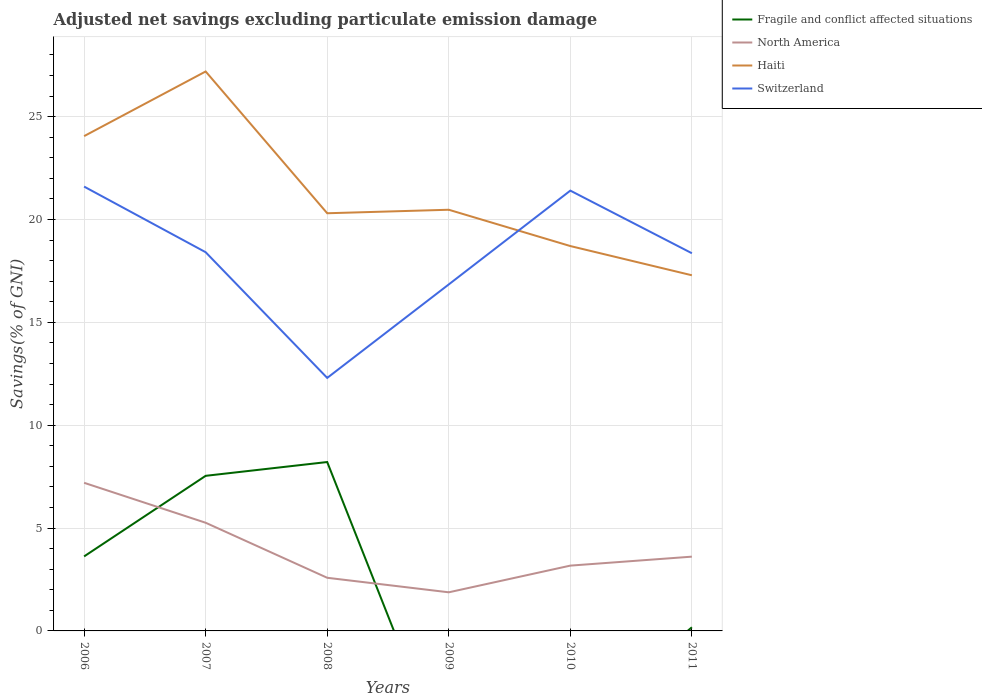How many different coloured lines are there?
Provide a succinct answer. 4. Is the number of lines equal to the number of legend labels?
Keep it short and to the point. No. Across all years, what is the maximum adjusted net savings in North America?
Offer a terse response. 1.88. What is the total adjusted net savings in Haiti in the graph?
Your response must be concise. 1.42. What is the difference between the highest and the second highest adjusted net savings in Haiti?
Provide a short and direct response. 9.91. How many years are there in the graph?
Give a very brief answer. 6. Does the graph contain any zero values?
Your answer should be compact. Yes. Does the graph contain grids?
Provide a succinct answer. Yes. Where does the legend appear in the graph?
Your answer should be compact. Top right. How many legend labels are there?
Ensure brevity in your answer.  4. What is the title of the graph?
Make the answer very short. Adjusted net savings excluding particulate emission damage. What is the label or title of the X-axis?
Provide a short and direct response. Years. What is the label or title of the Y-axis?
Offer a very short reply. Savings(% of GNI). What is the Savings(% of GNI) in Fragile and conflict affected situations in 2006?
Provide a succinct answer. 3.62. What is the Savings(% of GNI) of North America in 2006?
Make the answer very short. 7.2. What is the Savings(% of GNI) of Haiti in 2006?
Provide a short and direct response. 24.05. What is the Savings(% of GNI) in Switzerland in 2006?
Your response must be concise. 21.6. What is the Savings(% of GNI) in Fragile and conflict affected situations in 2007?
Keep it short and to the point. 7.54. What is the Savings(% of GNI) of North America in 2007?
Your answer should be very brief. 5.26. What is the Savings(% of GNI) in Haiti in 2007?
Offer a terse response. 27.19. What is the Savings(% of GNI) in Switzerland in 2007?
Your answer should be compact. 18.41. What is the Savings(% of GNI) of Fragile and conflict affected situations in 2008?
Offer a very short reply. 8.21. What is the Savings(% of GNI) in North America in 2008?
Keep it short and to the point. 2.58. What is the Savings(% of GNI) in Haiti in 2008?
Give a very brief answer. 20.3. What is the Savings(% of GNI) in Switzerland in 2008?
Provide a succinct answer. 12.3. What is the Savings(% of GNI) of Fragile and conflict affected situations in 2009?
Your response must be concise. 0. What is the Savings(% of GNI) in North America in 2009?
Provide a short and direct response. 1.88. What is the Savings(% of GNI) of Haiti in 2009?
Offer a terse response. 20.47. What is the Savings(% of GNI) in Switzerland in 2009?
Ensure brevity in your answer.  16.84. What is the Savings(% of GNI) of North America in 2010?
Your answer should be compact. 3.17. What is the Savings(% of GNI) in Haiti in 2010?
Your answer should be compact. 18.71. What is the Savings(% of GNI) of Switzerland in 2010?
Ensure brevity in your answer.  21.4. What is the Savings(% of GNI) in Fragile and conflict affected situations in 2011?
Offer a very short reply. 0.18. What is the Savings(% of GNI) of North America in 2011?
Provide a short and direct response. 3.61. What is the Savings(% of GNI) in Haiti in 2011?
Offer a very short reply. 17.29. What is the Savings(% of GNI) of Switzerland in 2011?
Your response must be concise. 18.36. Across all years, what is the maximum Savings(% of GNI) in Fragile and conflict affected situations?
Give a very brief answer. 8.21. Across all years, what is the maximum Savings(% of GNI) of North America?
Your answer should be compact. 7.2. Across all years, what is the maximum Savings(% of GNI) in Haiti?
Provide a short and direct response. 27.19. Across all years, what is the maximum Savings(% of GNI) of Switzerland?
Provide a succinct answer. 21.6. Across all years, what is the minimum Savings(% of GNI) of North America?
Your response must be concise. 1.88. Across all years, what is the minimum Savings(% of GNI) in Haiti?
Provide a succinct answer. 17.29. Across all years, what is the minimum Savings(% of GNI) in Switzerland?
Provide a succinct answer. 12.3. What is the total Savings(% of GNI) of Fragile and conflict affected situations in the graph?
Give a very brief answer. 19.55. What is the total Savings(% of GNI) in North America in the graph?
Your response must be concise. 23.7. What is the total Savings(% of GNI) in Haiti in the graph?
Provide a short and direct response. 128.02. What is the total Savings(% of GNI) of Switzerland in the graph?
Your response must be concise. 108.91. What is the difference between the Savings(% of GNI) in Fragile and conflict affected situations in 2006 and that in 2007?
Offer a very short reply. -3.92. What is the difference between the Savings(% of GNI) of North America in 2006 and that in 2007?
Your response must be concise. 1.94. What is the difference between the Savings(% of GNI) of Haiti in 2006 and that in 2007?
Provide a short and direct response. -3.14. What is the difference between the Savings(% of GNI) of Switzerland in 2006 and that in 2007?
Give a very brief answer. 3.19. What is the difference between the Savings(% of GNI) in Fragile and conflict affected situations in 2006 and that in 2008?
Provide a short and direct response. -4.59. What is the difference between the Savings(% of GNI) of North America in 2006 and that in 2008?
Keep it short and to the point. 4.62. What is the difference between the Savings(% of GNI) in Haiti in 2006 and that in 2008?
Your response must be concise. 3.75. What is the difference between the Savings(% of GNI) of Switzerland in 2006 and that in 2008?
Offer a very short reply. 9.3. What is the difference between the Savings(% of GNI) in North America in 2006 and that in 2009?
Offer a very short reply. 5.32. What is the difference between the Savings(% of GNI) of Haiti in 2006 and that in 2009?
Ensure brevity in your answer.  3.58. What is the difference between the Savings(% of GNI) of Switzerland in 2006 and that in 2009?
Offer a very short reply. 4.76. What is the difference between the Savings(% of GNI) of North America in 2006 and that in 2010?
Offer a very short reply. 4.03. What is the difference between the Savings(% of GNI) of Haiti in 2006 and that in 2010?
Offer a terse response. 5.34. What is the difference between the Savings(% of GNI) in Switzerland in 2006 and that in 2010?
Offer a terse response. 0.2. What is the difference between the Savings(% of GNI) of Fragile and conflict affected situations in 2006 and that in 2011?
Your answer should be compact. 3.44. What is the difference between the Savings(% of GNI) in North America in 2006 and that in 2011?
Provide a short and direct response. 3.59. What is the difference between the Savings(% of GNI) of Haiti in 2006 and that in 2011?
Offer a terse response. 6.76. What is the difference between the Savings(% of GNI) in Switzerland in 2006 and that in 2011?
Make the answer very short. 3.24. What is the difference between the Savings(% of GNI) in Fragile and conflict affected situations in 2007 and that in 2008?
Make the answer very short. -0.67. What is the difference between the Savings(% of GNI) in North America in 2007 and that in 2008?
Your response must be concise. 2.67. What is the difference between the Savings(% of GNI) of Haiti in 2007 and that in 2008?
Your answer should be very brief. 6.89. What is the difference between the Savings(% of GNI) of Switzerland in 2007 and that in 2008?
Your answer should be very brief. 6.11. What is the difference between the Savings(% of GNI) of North America in 2007 and that in 2009?
Offer a very short reply. 3.38. What is the difference between the Savings(% of GNI) in Haiti in 2007 and that in 2009?
Keep it short and to the point. 6.72. What is the difference between the Savings(% of GNI) in Switzerland in 2007 and that in 2009?
Give a very brief answer. 1.56. What is the difference between the Savings(% of GNI) in North America in 2007 and that in 2010?
Your answer should be compact. 2.08. What is the difference between the Savings(% of GNI) of Haiti in 2007 and that in 2010?
Give a very brief answer. 8.49. What is the difference between the Savings(% of GNI) in Switzerland in 2007 and that in 2010?
Provide a short and direct response. -2.99. What is the difference between the Savings(% of GNI) of Fragile and conflict affected situations in 2007 and that in 2011?
Keep it short and to the point. 7.36. What is the difference between the Savings(% of GNI) of North America in 2007 and that in 2011?
Your response must be concise. 1.65. What is the difference between the Savings(% of GNI) in Haiti in 2007 and that in 2011?
Your answer should be very brief. 9.91. What is the difference between the Savings(% of GNI) in Switzerland in 2007 and that in 2011?
Provide a short and direct response. 0.05. What is the difference between the Savings(% of GNI) in North America in 2008 and that in 2009?
Make the answer very short. 0.71. What is the difference between the Savings(% of GNI) of Haiti in 2008 and that in 2009?
Your answer should be compact. -0.17. What is the difference between the Savings(% of GNI) in Switzerland in 2008 and that in 2009?
Your answer should be very brief. -4.54. What is the difference between the Savings(% of GNI) in North America in 2008 and that in 2010?
Your response must be concise. -0.59. What is the difference between the Savings(% of GNI) of Haiti in 2008 and that in 2010?
Your answer should be very brief. 1.59. What is the difference between the Savings(% of GNI) of Switzerland in 2008 and that in 2010?
Offer a terse response. -9.1. What is the difference between the Savings(% of GNI) in Fragile and conflict affected situations in 2008 and that in 2011?
Provide a short and direct response. 8.03. What is the difference between the Savings(% of GNI) in North America in 2008 and that in 2011?
Make the answer very short. -1.03. What is the difference between the Savings(% of GNI) of Haiti in 2008 and that in 2011?
Your response must be concise. 3.02. What is the difference between the Savings(% of GNI) in Switzerland in 2008 and that in 2011?
Provide a short and direct response. -6.06. What is the difference between the Savings(% of GNI) in North America in 2009 and that in 2010?
Offer a very short reply. -1.3. What is the difference between the Savings(% of GNI) of Haiti in 2009 and that in 2010?
Your response must be concise. 1.77. What is the difference between the Savings(% of GNI) in Switzerland in 2009 and that in 2010?
Offer a terse response. -4.56. What is the difference between the Savings(% of GNI) of North America in 2009 and that in 2011?
Make the answer very short. -1.73. What is the difference between the Savings(% of GNI) in Haiti in 2009 and that in 2011?
Keep it short and to the point. 3.19. What is the difference between the Savings(% of GNI) of Switzerland in 2009 and that in 2011?
Ensure brevity in your answer.  -1.51. What is the difference between the Savings(% of GNI) of North America in 2010 and that in 2011?
Your answer should be compact. -0.44. What is the difference between the Savings(% of GNI) of Haiti in 2010 and that in 2011?
Give a very brief answer. 1.42. What is the difference between the Savings(% of GNI) in Switzerland in 2010 and that in 2011?
Provide a short and direct response. 3.04. What is the difference between the Savings(% of GNI) of Fragile and conflict affected situations in 2006 and the Savings(% of GNI) of North America in 2007?
Your response must be concise. -1.64. What is the difference between the Savings(% of GNI) of Fragile and conflict affected situations in 2006 and the Savings(% of GNI) of Haiti in 2007?
Provide a succinct answer. -23.57. What is the difference between the Savings(% of GNI) of Fragile and conflict affected situations in 2006 and the Savings(% of GNI) of Switzerland in 2007?
Provide a succinct answer. -14.79. What is the difference between the Savings(% of GNI) of North America in 2006 and the Savings(% of GNI) of Haiti in 2007?
Provide a succinct answer. -19.99. What is the difference between the Savings(% of GNI) of North America in 2006 and the Savings(% of GNI) of Switzerland in 2007?
Make the answer very short. -11.21. What is the difference between the Savings(% of GNI) in Haiti in 2006 and the Savings(% of GNI) in Switzerland in 2007?
Your response must be concise. 5.64. What is the difference between the Savings(% of GNI) in Fragile and conflict affected situations in 2006 and the Savings(% of GNI) in North America in 2008?
Keep it short and to the point. 1.04. What is the difference between the Savings(% of GNI) of Fragile and conflict affected situations in 2006 and the Savings(% of GNI) of Haiti in 2008?
Your response must be concise. -16.68. What is the difference between the Savings(% of GNI) of Fragile and conflict affected situations in 2006 and the Savings(% of GNI) of Switzerland in 2008?
Ensure brevity in your answer.  -8.68. What is the difference between the Savings(% of GNI) of North America in 2006 and the Savings(% of GNI) of Haiti in 2008?
Your answer should be very brief. -13.1. What is the difference between the Savings(% of GNI) in North America in 2006 and the Savings(% of GNI) in Switzerland in 2008?
Offer a terse response. -5.1. What is the difference between the Savings(% of GNI) of Haiti in 2006 and the Savings(% of GNI) of Switzerland in 2008?
Your response must be concise. 11.75. What is the difference between the Savings(% of GNI) of Fragile and conflict affected situations in 2006 and the Savings(% of GNI) of North America in 2009?
Offer a very short reply. 1.74. What is the difference between the Savings(% of GNI) of Fragile and conflict affected situations in 2006 and the Savings(% of GNI) of Haiti in 2009?
Provide a short and direct response. -16.85. What is the difference between the Savings(% of GNI) of Fragile and conflict affected situations in 2006 and the Savings(% of GNI) of Switzerland in 2009?
Your answer should be very brief. -13.22. What is the difference between the Savings(% of GNI) in North America in 2006 and the Savings(% of GNI) in Haiti in 2009?
Ensure brevity in your answer.  -13.27. What is the difference between the Savings(% of GNI) of North America in 2006 and the Savings(% of GNI) of Switzerland in 2009?
Provide a succinct answer. -9.64. What is the difference between the Savings(% of GNI) of Haiti in 2006 and the Savings(% of GNI) of Switzerland in 2009?
Provide a succinct answer. 7.21. What is the difference between the Savings(% of GNI) in Fragile and conflict affected situations in 2006 and the Savings(% of GNI) in North America in 2010?
Keep it short and to the point. 0.45. What is the difference between the Savings(% of GNI) in Fragile and conflict affected situations in 2006 and the Savings(% of GNI) in Haiti in 2010?
Ensure brevity in your answer.  -15.09. What is the difference between the Savings(% of GNI) in Fragile and conflict affected situations in 2006 and the Savings(% of GNI) in Switzerland in 2010?
Provide a succinct answer. -17.78. What is the difference between the Savings(% of GNI) of North America in 2006 and the Savings(% of GNI) of Haiti in 2010?
Provide a short and direct response. -11.51. What is the difference between the Savings(% of GNI) of North America in 2006 and the Savings(% of GNI) of Switzerland in 2010?
Keep it short and to the point. -14.2. What is the difference between the Savings(% of GNI) in Haiti in 2006 and the Savings(% of GNI) in Switzerland in 2010?
Offer a terse response. 2.65. What is the difference between the Savings(% of GNI) in Fragile and conflict affected situations in 2006 and the Savings(% of GNI) in North America in 2011?
Your response must be concise. 0.01. What is the difference between the Savings(% of GNI) in Fragile and conflict affected situations in 2006 and the Savings(% of GNI) in Haiti in 2011?
Offer a very short reply. -13.67. What is the difference between the Savings(% of GNI) of Fragile and conflict affected situations in 2006 and the Savings(% of GNI) of Switzerland in 2011?
Ensure brevity in your answer.  -14.74. What is the difference between the Savings(% of GNI) of North America in 2006 and the Savings(% of GNI) of Haiti in 2011?
Make the answer very short. -10.09. What is the difference between the Savings(% of GNI) of North America in 2006 and the Savings(% of GNI) of Switzerland in 2011?
Make the answer very short. -11.16. What is the difference between the Savings(% of GNI) in Haiti in 2006 and the Savings(% of GNI) in Switzerland in 2011?
Keep it short and to the point. 5.69. What is the difference between the Savings(% of GNI) of Fragile and conflict affected situations in 2007 and the Savings(% of GNI) of North America in 2008?
Provide a succinct answer. 4.96. What is the difference between the Savings(% of GNI) of Fragile and conflict affected situations in 2007 and the Savings(% of GNI) of Haiti in 2008?
Your answer should be very brief. -12.76. What is the difference between the Savings(% of GNI) in Fragile and conflict affected situations in 2007 and the Savings(% of GNI) in Switzerland in 2008?
Keep it short and to the point. -4.76. What is the difference between the Savings(% of GNI) of North America in 2007 and the Savings(% of GNI) of Haiti in 2008?
Provide a short and direct response. -15.04. What is the difference between the Savings(% of GNI) of North America in 2007 and the Savings(% of GNI) of Switzerland in 2008?
Provide a succinct answer. -7.04. What is the difference between the Savings(% of GNI) of Haiti in 2007 and the Savings(% of GNI) of Switzerland in 2008?
Provide a short and direct response. 14.9. What is the difference between the Savings(% of GNI) in Fragile and conflict affected situations in 2007 and the Savings(% of GNI) in North America in 2009?
Provide a short and direct response. 5.66. What is the difference between the Savings(% of GNI) of Fragile and conflict affected situations in 2007 and the Savings(% of GNI) of Haiti in 2009?
Offer a terse response. -12.93. What is the difference between the Savings(% of GNI) of Fragile and conflict affected situations in 2007 and the Savings(% of GNI) of Switzerland in 2009?
Make the answer very short. -9.3. What is the difference between the Savings(% of GNI) in North America in 2007 and the Savings(% of GNI) in Haiti in 2009?
Offer a terse response. -15.22. What is the difference between the Savings(% of GNI) in North America in 2007 and the Savings(% of GNI) in Switzerland in 2009?
Provide a short and direct response. -11.59. What is the difference between the Savings(% of GNI) of Haiti in 2007 and the Savings(% of GNI) of Switzerland in 2009?
Provide a succinct answer. 10.35. What is the difference between the Savings(% of GNI) of Fragile and conflict affected situations in 2007 and the Savings(% of GNI) of North America in 2010?
Offer a terse response. 4.36. What is the difference between the Savings(% of GNI) in Fragile and conflict affected situations in 2007 and the Savings(% of GNI) in Haiti in 2010?
Ensure brevity in your answer.  -11.17. What is the difference between the Savings(% of GNI) of Fragile and conflict affected situations in 2007 and the Savings(% of GNI) of Switzerland in 2010?
Give a very brief answer. -13.86. What is the difference between the Savings(% of GNI) in North America in 2007 and the Savings(% of GNI) in Haiti in 2010?
Offer a terse response. -13.45. What is the difference between the Savings(% of GNI) in North America in 2007 and the Savings(% of GNI) in Switzerland in 2010?
Your answer should be very brief. -16.14. What is the difference between the Savings(% of GNI) of Haiti in 2007 and the Savings(% of GNI) of Switzerland in 2010?
Make the answer very short. 5.79. What is the difference between the Savings(% of GNI) of Fragile and conflict affected situations in 2007 and the Savings(% of GNI) of North America in 2011?
Offer a very short reply. 3.93. What is the difference between the Savings(% of GNI) in Fragile and conflict affected situations in 2007 and the Savings(% of GNI) in Haiti in 2011?
Give a very brief answer. -9.75. What is the difference between the Savings(% of GNI) of Fragile and conflict affected situations in 2007 and the Savings(% of GNI) of Switzerland in 2011?
Your answer should be very brief. -10.82. What is the difference between the Savings(% of GNI) in North America in 2007 and the Savings(% of GNI) in Haiti in 2011?
Your answer should be very brief. -12.03. What is the difference between the Savings(% of GNI) in North America in 2007 and the Savings(% of GNI) in Switzerland in 2011?
Keep it short and to the point. -13.1. What is the difference between the Savings(% of GNI) of Haiti in 2007 and the Savings(% of GNI) of Switzerland in 2011?
Offer a terse response. 8.84. What is the difference between the Savings(% of GNI) of Fragile and conflict affected situations in 2008 and the Savings(% of GNI) of North America in 2009?
Your response must be concise. 6.33. What is the difference between the Savings(% of GNI) of Fragile and conflict affected situations in 2008 and the Savings(% of GNI) of Haiti in 2009?
Your response must be concise. -12.26. What is the difference between the Savings(% of GNI) in Fragile and conflict affected situations in 2008 and the Savings(% of GNI) in Switzerland in 2009?
Provide a short and direct response. -8.63. What is the difference between the Savings(% of GNI) of North America in 2008 and the Savings(% of GNI) of Haiti in 2009?
Provide a short and direct response. -17.89. What is the difference between the Savings(% of GNI) in North America in 2008 and the Savings(% of GNI) in Switzerland in 2009?
Keep it short and to the point. -14.26. What is the difference between the Savings(% of GNI) of Haiti in 2008 and the Savings(% of GNI) of Switzerland in 2009?
Your response must be concise. 3.46. What is the difference between the Savings(% of GNI) in Fragile and conflict affected situations in 2008 and the Savings(% of GNI) in North America in 2010?
Keep it short and to the point. 5.04. What is the difference between the Savings(% of GNI) in Fragile and conflict affected situations in 2008 and the Savings(% of GNI) in Haiti in 2010?
Offer a terse response. -10.5. What is the difference between the Savings(% of GNI) in Fragile and conflict affected situations in 2008 and the Savings(% of GNI) in Switzerland in 2010?
Your response must be concise. -13.19. What is the difference between the Savings(% of GNI) of North America in 2008 and the Savings(% of GNI) of Haiti in 2010?
Make the answer very short. -16.13. What is the difference between the Savings(% of GNI) of North America in 2008 and the Savings(% of GNI) of Switzerland in 2010?
Offer a terse response. -18.82. What is the difference between the Savings(% of GNI) of Haiti in 2008 and the Savings(% of GNI) of Switzerland in 2010?
Provide a short and direct response. -1.1. What is the difference between the Savings(% of GNI) of Fragile and conflict affected situations in 2008 and the Savings(% of GNI) of North America in 2011?
Provide a short and direct response. 4.6. What is the difference between the Savings(% of GNI) of Fragile and conflict affected situations in 2008 and the Savings(% of GNI) of Haiti in 2011?
Offer a very short reply. -9.08. What is the difference between the Savings(% of GNI) in Fragile and conflict affected situations in 2008 and the Savings(% of GNI) in Switzerland in 2011?
Provide a short and direct response. -10.15. What is the difference between the Savings(% of GNI) in North America in 2008 and the Savings(% of GNI) in Haiti in 2011?
Provide a succinct answer. -14.7. What is the difference between the Savings(% of GNI) in North America in 2008 and the Savings(% of GNI) in Switzerland in 2011?
Your answer should be very brief. -15.78. What is the difference between the Savings(% of GNI) in Haiti in 2008 and the Savings(% of GNI) in Switzerland in 2011?
Your answer should be compact. 1.94. What is the difference between the Savings(% of GNI) in North America in 2009 and the Savings(% of GNI) in Haiti in 2010?
Your answer should be compact. -16.83. What is the difference between the Savings(% of GNI) in North America in 2009 and the Savings(% of GNI) in Switzerland in 2010?
Your answer should be very brief. -19.53. What is the difference between the Savings(% of GNI) of Haiti in 2009 and the Savings(% of GNI) of Switzerland in 2010?
Make the answer very short. -0.93. What is the difference between the Savings(% of GNI) of North America in 2009 and the Savings(% of GNI) of Haiti in 2011?
Make the answer very short. -15.41. What is the difference between the Savings(% of GNI) in North America in 2009 and the Savings(% of GNI) in Switzerland in 2011?
Offer a very short reply. -16.48. What is the difference between the Savings(% of GNI) in Haiti in 2009 and the Savings(% of GNI) in Switzerland in 2011?
Give a very brief answer. 2.11. What is the difference between the Savings(% of GNI) in North America in 2010 and the Savings(% of GNI) in Haiti in 2011?
Your response must be concise. -14.11. What is the difference between the Savings(% of GNI) in North America in 2010 and the Savings(% of GNI) in Switzerland in 2011?
Offer a very short reply. -15.18. What is the difference between the Savings(% of GNI) of Haiti in 2010 and the Savings(% of GNI) of Switzerland in 2011?
Keep it short and to the point. 0.35. What is the average Savings(% of GNI) of Fragile and conflict affected situations per year?
Your answer should be compact. 3.26. What is the average Savings(% of GNI) in North America per year?
Your response must be concise. 3.95. What is the average Savings(% of GNI) in Haiti per year?
Give a very brief answer. 21.34. What is the average Savings(% of GNI) in Switzerland per year?
Your answer should be very brief. 18.15. In the year 2006, what is the difference between the Savings(% of GNI) in Fragile and conflict affected situations and Savings(% of GNI) in North America?
Your answer should be compact. -3.58. In the year 2006, what is the difference between the Savings(% of GNI) in Fragile and conflict affected situations and Savings(% of GNI) in Haiti?
Your response must be concise. -20.43. In the year 2006, what is the difference between the Savings(% of GNI) of Fragile and conflict affected situations and Savings(% of GNI) of Switzerland?
Your response must be concise. -17.98. In the year 2006, what is the difference between the Savings(% of GNI) of North America and Savings(% of GNI) of Haiti?
Keep it short and to the point. -16.85. In the year 2006, what is the difference between the Savings(% of GNI) in North America and Savings(% of GNI) in Switzerland?
Provide a short and direct response. -14.4. In the year 2006, what is the difference between the Savings(% of GNI) of Haiti and Savings(% of GNI) of Switzerland?
Your answer should be very brief. 2.45. In the year 2007, what is the difference between the Savings(% of GNI) of Fragile and conflict affected situations and Savings(% of GNI) of North America?
Your response must be concise. 2.28. In the year 2007, what is the difference between the Savings(% of GNI) in Fragile and conflict affected situations and Savings(% of GNI) in Haiti?
Ensure brevity in your answer.  -19.66. In the year 2007, what is the difference between the Savings(% of GNI) of Fragile and conflict affected situations and Savings(% of GNI) of Switzerland?
Give a very brief answer. -10.87. In the year 2007, what is the difference between the Savings(% of GNI) in North America and Savings(% of GNI) in Haiti?
Your response must be concise. -21.94. In the year 2007, what is the difference between the Savings(% of GNI) in North America and Savings(% of GNI) in Switzerland?
Offer a very short reply. -13.15. In the year 2007, what is the difference between the Savings(% of GNI) in Haiti and Savings(% of GNI) in Switzerland?
Ensure brevity in your answer.  8.79. In the year 2008, what is the difference between the Savings(% of GNI) in Fragile and conflict affected situations and Savings(% of GNI) in North America?
Offer a very short reply. 5.63. In the year 2008, what is the difference between the Savings(% of GNI) of Fragile and conflict affected situations and Savings(% of GNI) of Haiti?
Give a very brief answer. -12.09. In the year 2008, what is the difference between the Savings(% of GNI) in Fragile and conflict affected situations and Savings(% of GNI) in Switzerland?
Ensure brevity in your answer.  -4.09. In the year 2008, what is the difference between the Savings(% of GNI) of North America and Savings(% of GNI) of Haiti?
Keep it short and to the point. -17.72. In the year 2008, what is the difference between the Savings(% of GNI) of North America and Savings(% of GNI) of Switzerland?
Keep it short and to the point. -9.72. In the year 2008, what is the difference between the Savings(% of GNI) in Haiti and Savings(% of GNI) in Switzerland?
Your response must be concise. 8. In the year 2009, what is the difference between the Savings(% of GNI) of North America and Savings(% of GNI) of Haiti?
Keep it short and to the point. -18.6. In the year 2009, what is the difference between the Savings(% of GNI) in North America and Savings(% of GNI) in Switzerland?
Offer a very short reply. -14.97. In the year 2009, what is the difference between the Savings(% of GNI) of Haiti and Savings(% of GNI) of Switzerland?
Offer a very short reply. 3.63. In the year 2010, what is the difference between the Savings(% of GNI) of North America and Savings(% of GNI) of Haiti?
Ensure brevity in your answer.  -15.53. In the year 2010, what is the difference between the Savings(% of GNI) in North America and Savings(% of GNI) in Switzerland?
Give a very brief answer. -18.23. In the year 2010, what is the difference between the Savings(% of GNI) in Haiti and Savings(% of GNI) in Switzerland?
Keep it short and to the point. -2.69. In the year 2011, what is the difference between the Savings(% of GNI) in Fragile and conflict affected situations and Savings(% of GNI) in North America?
Offer a terse response. -3.43. In the year 2011, what is the difference between the Savings(% of GNI) in Fragile and conflict affected situations and Savings(% of GNI) in Haiti?
Your answer should be very brief. -17.11. In the year 2011, what is the difference between the Savings(% of GNI) in Fragile and conflict affected situations and Savings(% of GNI) in Switzerland?
Your answer should be very brief. -18.18. In the year 2011, what is the difference between the Savings(% of GNI) in North America and Savings(% of GNI) in Haiti?
Give a very brief answer. -13.68. In the year 2011, what is the difference between the Savings(% of GNI) of North America and Savings(% of GNI) of Switzerland?
Provide a succinct answer. -14.75. In the year 2011, what is the difference between the Savings(% of GNI) in Haiti and Savings(% of GNI) in Switzerland?
Provide a short and direct response. -1.07. What is the ratio of the Savings(% of GNI) in Fragile and conflict affected situations in 2006 to that in 2007?
Your answer should be very brief. 0.48. What is the ratio of the Savings(% of GNI) in North America in 2006 to that in 2007?
Provide a succinct answer. 1.37. What is the ratio of the Savings(% of GNI) in Haiti in 2006 to that in 2007?
Give a very brief answer. 0.88. What is the ratio of the Savings(% of GNI) of Switzerland in 2006 to that in 2007?
Your answer should be compact. 1.17. What is the ratio of the Savings(% of GNI) in Fragile and conflict affected situations in 2006 to that in 2008?
Keep it short and to the point. 0.44. What is the ratio of the Savings(% of GNI) in North America in 2006 to that in 2008?
Offer a terse response. 2.79. What is the ratio of the Savings(% of GNI) of Haiti in 2006 to that in 2008?
Make the answer very short. 1.18. What is the ratio of the Savings(% of GNI) in Switzerland in 2006 to that in 2008?
Provide a succinct answer. 1.76. What is the ratio of the Savings(% of GNI) in North America in 2006 to that in 2009?
Provide a short and direct response. 3.84. What is the ratio of the Savings(% of GNI) in Haiti in 2006 to that in 2009?
Make the answer very short. 1.17. What is the ratio of the Savings(% of GNI) of Switzerland in 2006 to that in 2009?
Your answer should be very brief. 1.28. What is the ratio of the Savings(% of GNI) in North America in 2006 to that in 2010?
Offer a terse response. 2.27. What is the ratio of the Savings(% of GNI) of Switzerland in 2006 to that in 2010?
Give a very brief answer. 1.01. What is the ratio of the Savings(% of GNI) of Fragile and conflict affected situations in 2006 to that in 2011?
Keep it short and to the point. 20.31. What is the ratio of the Savings(% of GNI) of North America in 2006 to that in 2011?
Keep it short and to the point. 1.99. What is the ratio of the Savings(% of GNI) in Haiti in 2006 to that in 2011?
Your answer should be very brief. 1.39. What is the ratio of the Savings(% of GNI) in Switzerland in 2006 to that in 2011?
Your answer should be very brief. 1.18. What is the ratio of the Savings(% of GNI) in Fragile and conflict affected situations in 2007 to that in 2008?
Keep it short and to the point. 0.92. What is the ratio of the Savings(% of GNI) in North America in 2007 to that in 2008?
Your answer should be very brief. 2.04. What is the ratio of the Savings(% of GNI) of Haiti in 2007 to that in 2008?
Your answer should be very brief. 1.34. What is the ratio of the Savings(% of GNI) of Switzerland in 2007 to that in 2008?
Your answer should be compact. 1.5. What is the ratio of the Savings(% of GNI) in North America in 2007 to that in 2009?
Your response must be concise. 2.8. What is the ratio of the Savings(% of GNI) of Haiti in 2007 to that in 2009?
Provide a succinct answer. 1.33. What is the ratio of the Savings(% of GNI) in Switzerland in 2007 to that in 2009?
Offer a very short reply. 1.09. What is the ratio of the Savings(% of GNI) of North America in 2007 to that in 2010?
Your response must be concise. 1.66. What is the ratio of the Savings(% of GNI) of Haiti in 2007 to that in 2010?
Give a very brief answer. 1.45. What is the ratio of the Savings(% of GNI) in Switzerland in 2007 to that in 2010?
Provide a succinct answer. 0.86. What is the ratio of the Savings(% of GNI) in Fragile and conflict affected situations in 2007 to that in 2011?
Provide a short and direct response. 42.28. What is the ratio of the Savings(% of GNI) in North America in 2007 to that in 2011?
Offer a terse response. 1.46. What is the ratio of the Savings(% of GNI) in Haiti in 2007 to that in 2011?
Offer a terse response. 1.57. What is the ratio of the Savings(% of GNI) of Switzerland in 2007 to that in 2011?
Offer a terse response. 1. What is the ratio of the Savings(% of GNI) in North America in 2008 to that in 2009?
Make the answer very short. 1.38. What is the ratio of the Savings(% of GNI) in Haiti in 2008 to that in 2009?
Offer a terse response. 0.99. What is the ratio of the Savings(% of GNI) in Switzerland in 2008 to that in 2009?
Make the answer very short. 0.73. What is the ratio of the Savings(% of GNI) of North America in 2008 to that in 2010?
Offer a very short reply. 0.81. What is the ratio of the Savings(% of GNI) of Haiti in 2008 to that in 2010?
Give a very brief answer. 1.09. What is the ratio of the Savings(% of GNI) of Switzerland in 2008 to that in 2010?
Ensure brevity in your answer.  0.57. What is the ratio of the Savings(% of GNI) in Fragile and conflict affected situations in 2008 to that in 2011?
Offer a very short reply. 46.04. What is the ratio of the Savings(% of GNI) of North America in 2008 to that in 2011?
Make the answer very short. 0.72. What is the ratio of the Savings(% of GNI) of Haiti in 2008 to that in 2011?
Make the answer very short. 1.17. What is the ratio of the Savings(% of GNI) in Switzerland in 2008 to that in 2011?
Your answer should be compact. 0.67. What is the ratio of the Savings(% of GNI) in North America in 2009 to that in 2010?
Make the answer very short. 0.59. What is the ratio of the Savings(% of GNI) in Haiti in 2009 to that in 2010?
Make the answer very short. 1.09. What is the ratio of the Savings(% of GNI) in Switzerland in 2009 to that in 2010?
Provide a succinct answer. 0.79. What is the ratio of the Savings(% of GNI) in North America in 2009 to that in 2011?
Your answer should be very brief. 0.52. What is the ratio of the Savings(% of GNI) of Haiti in 2009 to that in 2011?
Give a very brief answer. 1.18. What is the ratio of the Savings(% of GNI) in Switzerland in 2009 to that in 2011?
Ensure brevity in your answer.  0.92. What is the ratio of the Savings(% of GNI) of North America in 2010 to that in 2011?
Give a very brief answer. 0.88. What is the ratio of the Savings(% of GNI) in Haiti in 2010 to that in 2011?
Your response must be concise. 1.08. What is the ratio of the Savings(% of GNI) of Switzerland in 2010 to that in 2011?
Make the answer very short. 1.17. What is the difference between the highest and the second highest Savings(% of GNI) in Fragile and conflict affected situations?
Offer a very short reply. 0.67. What is the difference between the highest and the second highest Savings(% of GNI) in North America?
Provide a succinct answer. 1.94. What is the difference between the highest and the second highest Savings(% of GNI) of Haiti?
Ensure brevity in your answer.  3.14. What is the difference between the highest and the second highest Savings(% of GNI) in Switzerland?
Provide a short and direct response. 0.2. What is the difference between the highest and the lowest Savings(% of GNI) of Fragile and conflict affected situations?
Keep it short and to the point. 8.21. What is the difference between the highest and the lowest Savings(% of GNI) in North America?
Keep it short and to the point. 5.32. What is the difference between the highest and the lowest Savings(% of GNI) in Haiti?
Ensure brevity in your answer.  9.91. What is the difference between the highest and the lowest Savings(% of GNI) of Switzerland?
Offer a terse response. 9.3. 